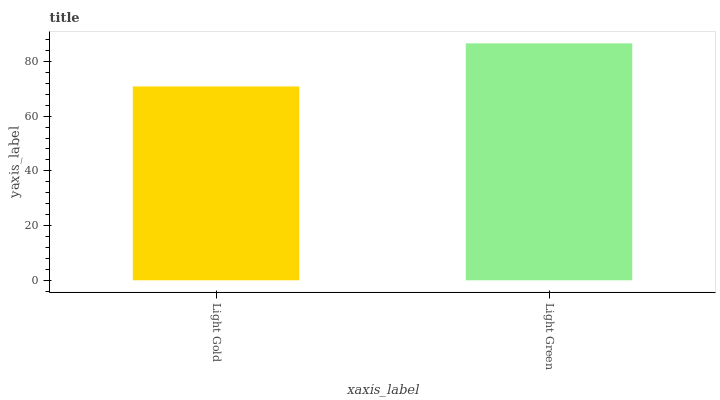Is Light Gold the minimum?
Answer yes or no. Yes. Is Light Green the maximum?
Answer yes or no. Yes. Is Light Green the minimum?
Answer yes or no. No. Is Light Green greater than Light Gold?
Answer yes or no. Yes. Is Light Gold less than Light Green?
Answer yes or no. Yes. Is Light Gold greater than Light Green?
Answer yes or no. No. Is Light Green less than Light Gold?
Answer yes or no. No. Is Light Green the high median?
Answer yes or no. Yes. Is Light Gold the low median?
Answer yes or no. Yes. Is Light Gold the high median?
Answer yes or no. No. Is Light Green the low median?
Answer yes or no. No. 